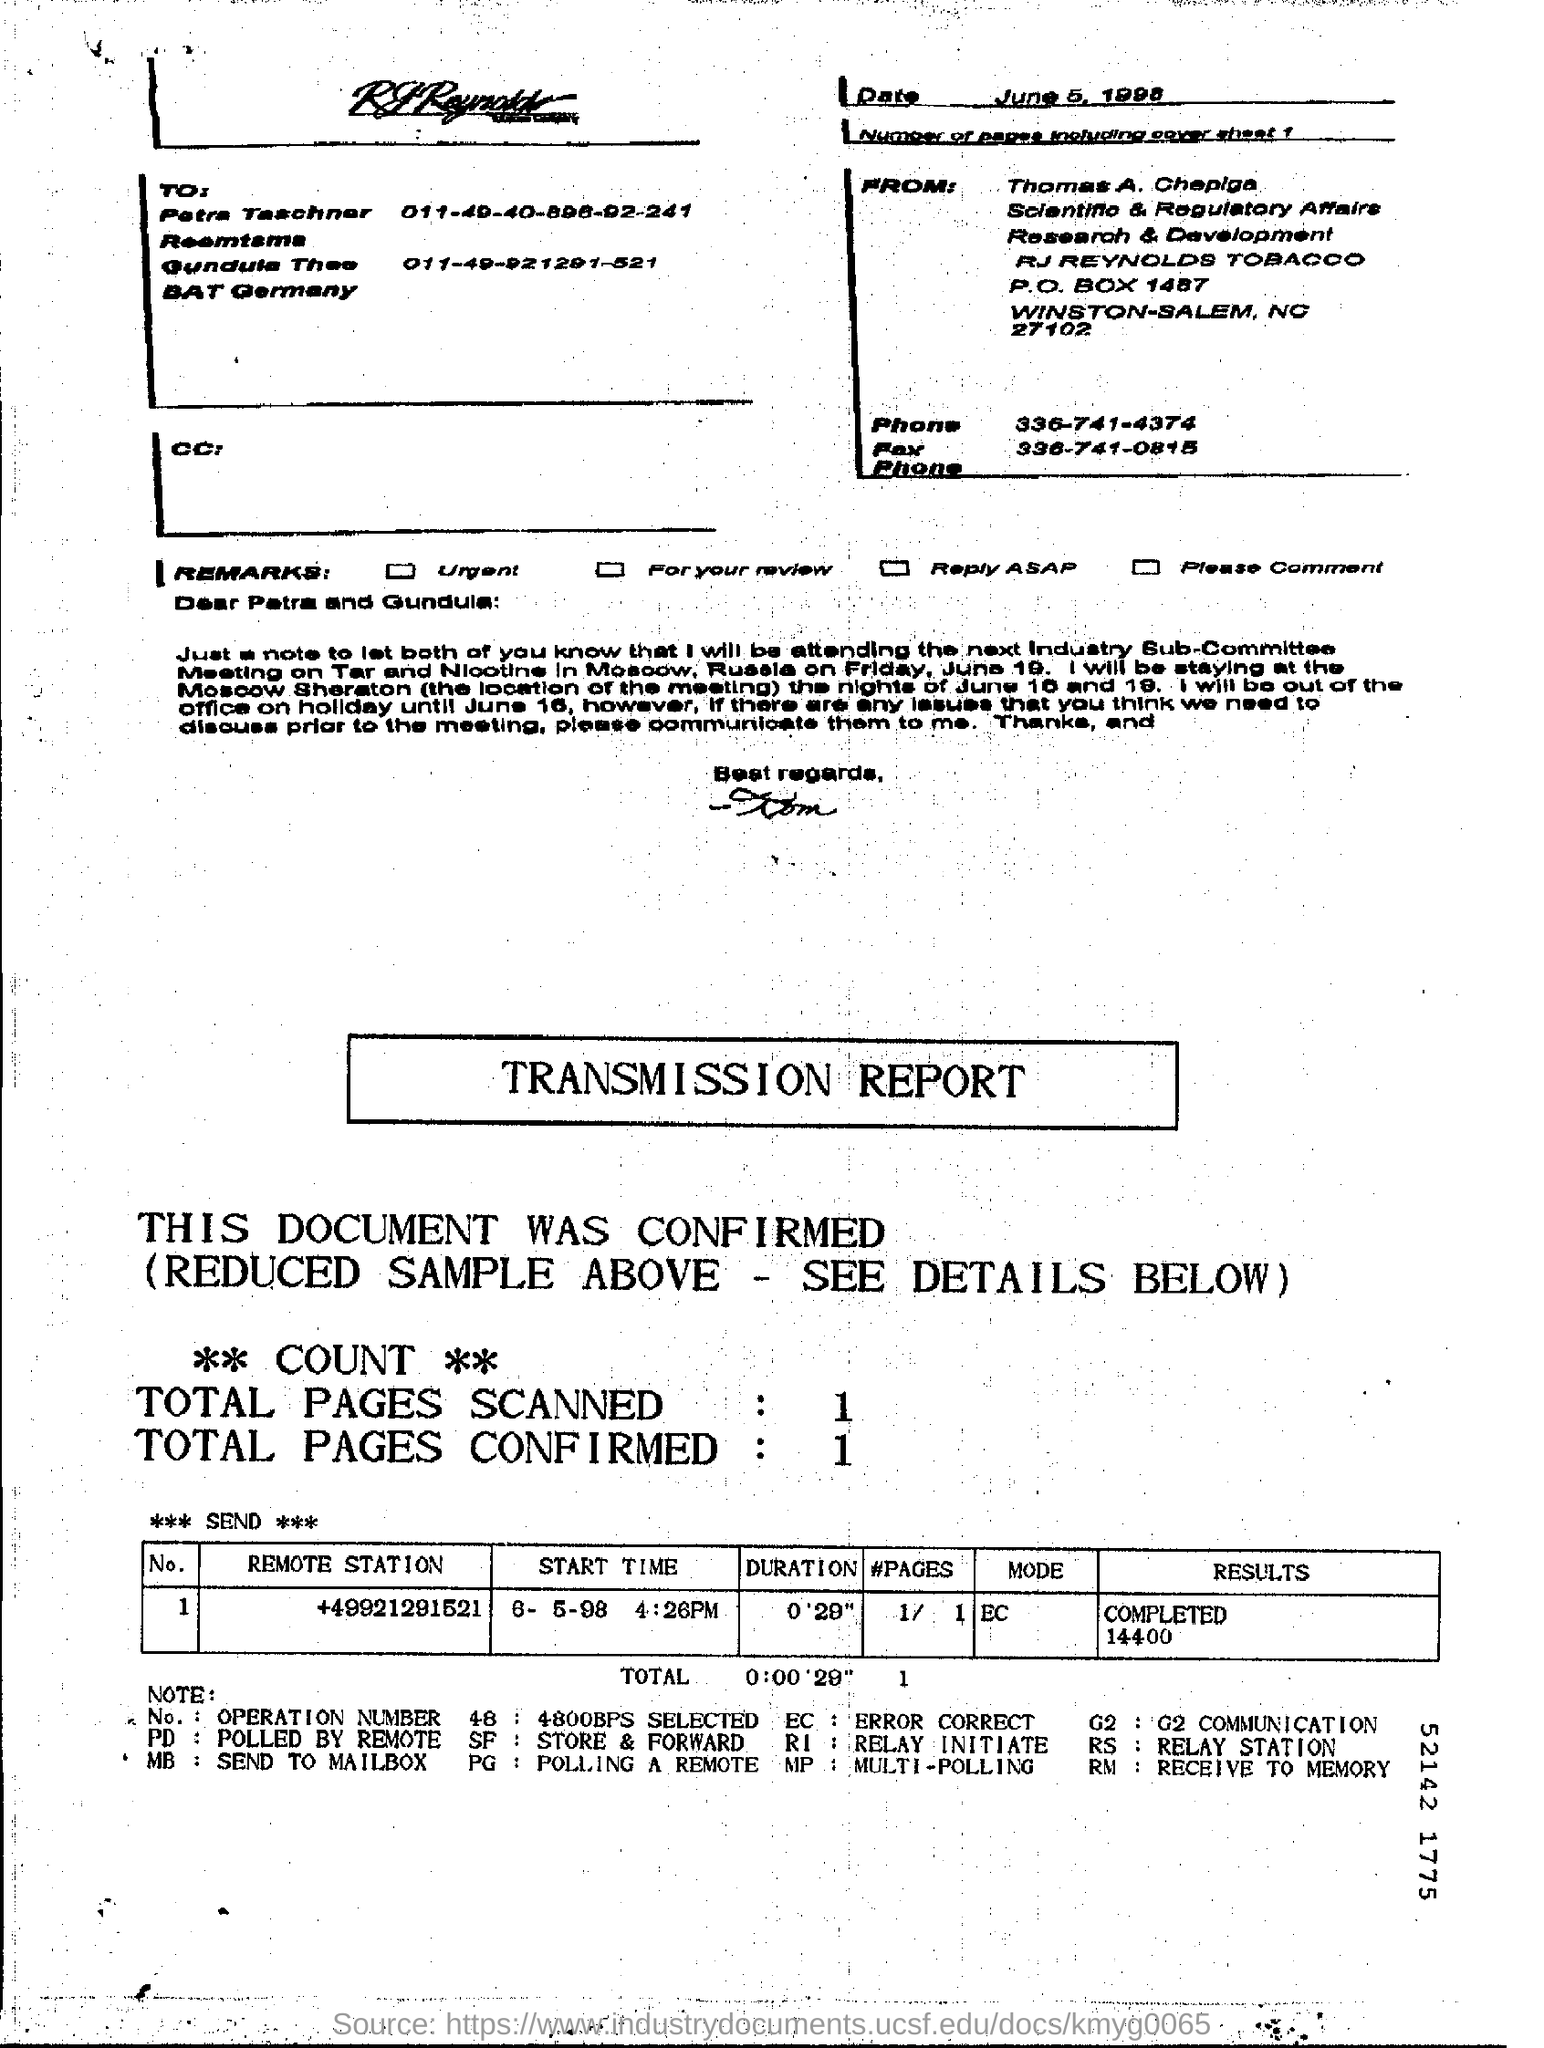In total how many pages were confirmed? The transmitted document consisted of a total of 1 page, as confirmed in the transmission report displayed in the image. 